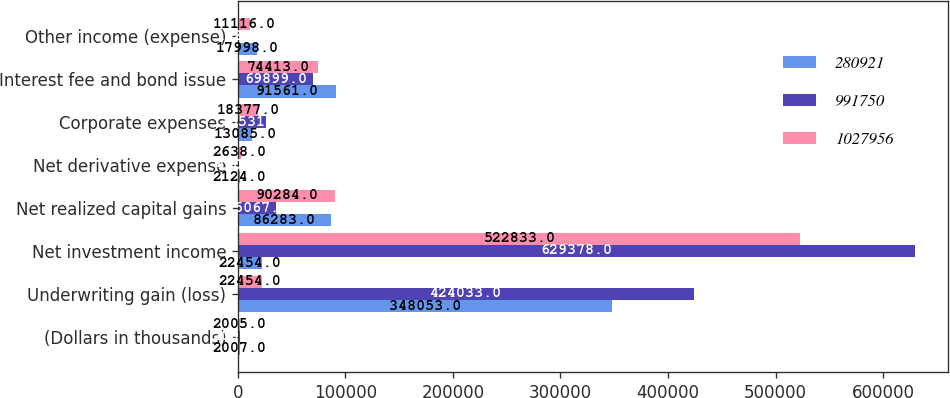Convert chart. <chart><loc_0><loc_0><loc_500><loc_500><stacked_bar_chart><ecel><fcel>(Dollars in thousands)<fcel>Underwriting gain (loss)<fcel>Net investment income<fcel>Net realized capital gains<fcel>Net derivative expense<fcel>Corporate expenses<fcel>Interest fee and bond issue<fcel>Other income (expense)<nl><fcel>280921<fcel>2007<fcel>348053<fcel>22454<fcel>86283<fcel>2124<fcel>13085<fcel>91561<fcel>17998<nl><fcel>991750<fcel>2006<fcel>424033<fcel>629378<fcel>35067<fcel>410<fcel>26531<fcel>69899<fcel>112<nl><fcel>1.02796e+06<fcel>2005<fcel>22454<fcel>522833<fcel>90284<fcel>2638<fcel>18377<fcel>74413<fcel>11116<nl></chart> 